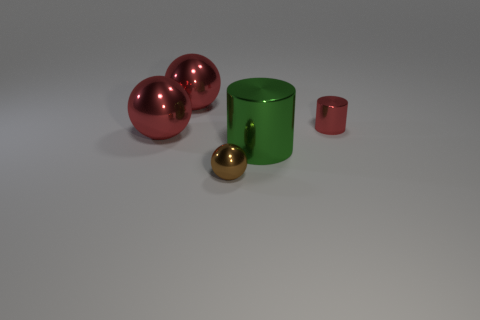Add 1 tiny brown metal objects. How many objects exist? 6 Subtract all balls. How many objects are left? 2 Add 1 gray objects. How many gray objects exist? 1 Subtract 0 purple balls. How many objects are left? 5 Subtract all big spheres. Subtract all large red shiny balls. How many objects are left? 1 Add 4 big metal objects. How many big metal objects are left? 7 